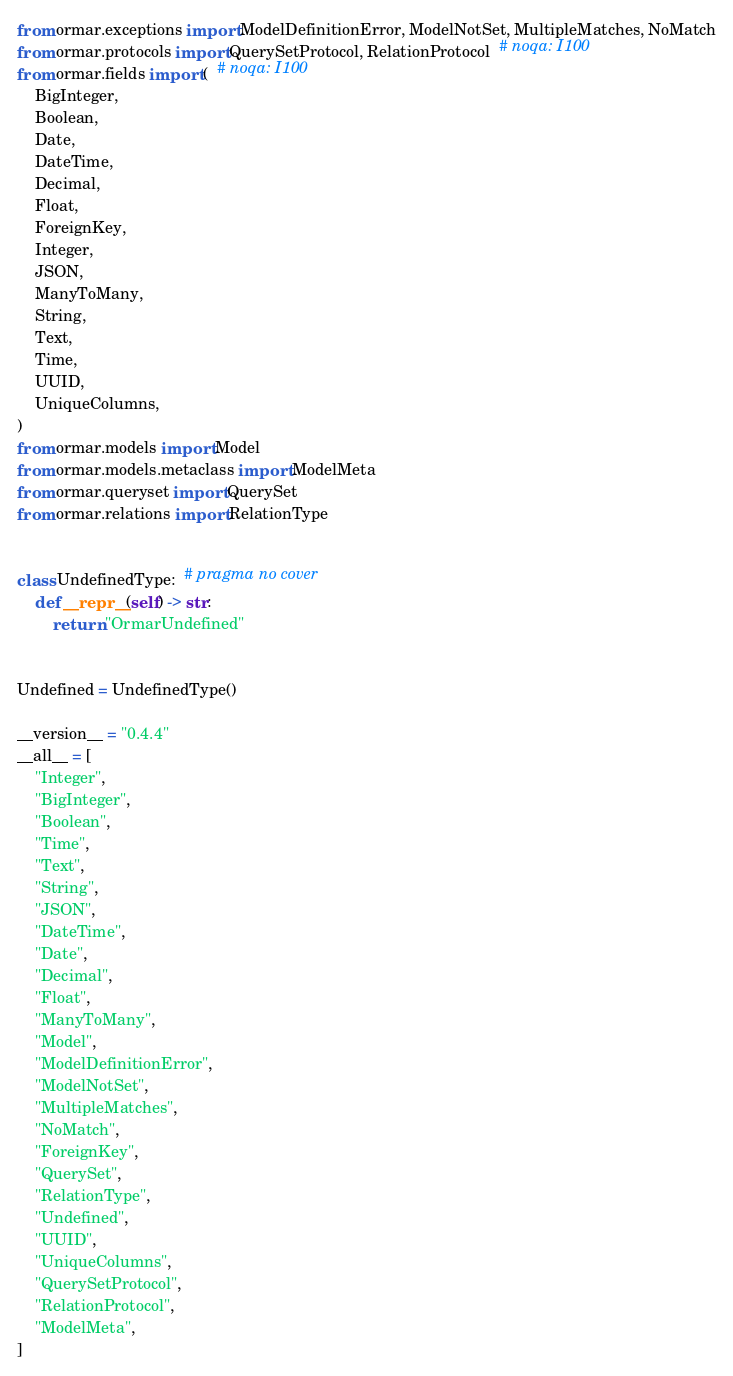Convert code to text. <code><loc_0><loc_0><loc_500><loc_500><_Python_>from ormar.exceptions import ModelDefinitionError, ModelNotSet, MultipleMatches, NoMatch
from ormar.protocols import QuerySetProtocol, RelationProtocol  # noqa: I100
from ormar.fields import (  # noqa: I100
    BigInteger,
    Boolean,
    Date,
    DateTime,
    Decimal,
    Float,
    ForeignKey,
    Integer,
    JSON,
    ManyToMany,
    String,
    Text,
    Time,
    UUID,
    UniqueColumns,
)
from ormar.models import Model
from ormar.models.metaclass import ModelMeta
from ormar.queryset import QuerySet
from ormar.relations import RelationType


class UndefinedType:  # pragma no cover
    def __repr__(self) -> str:
        return "OrmarUndefined"


Undefined = UndefinedType()

__version__ = "0.4.4"
__all__ = [
    "Integer",
    "BigInteger",
    "Boolean",
    "Time",
    "Text",
    "String",
    "JSON",
    "DateTime",
    "Date",
    "Decimal",
    "Float",
    "ManyToMany",
    "Model",
    "ModelDefinitionError",
    "ModelNotSet",
    "MultipleMatches",
    "NoMatch",
    "ForeignKey",
    "QuerySet",
    "RelationType",
    "Undefined",
    "UUID",
    "UniqueColumns",
    "QuerySetProtocol",
    "RelationProtocol",
    "ModelMeta",
]
</code> 